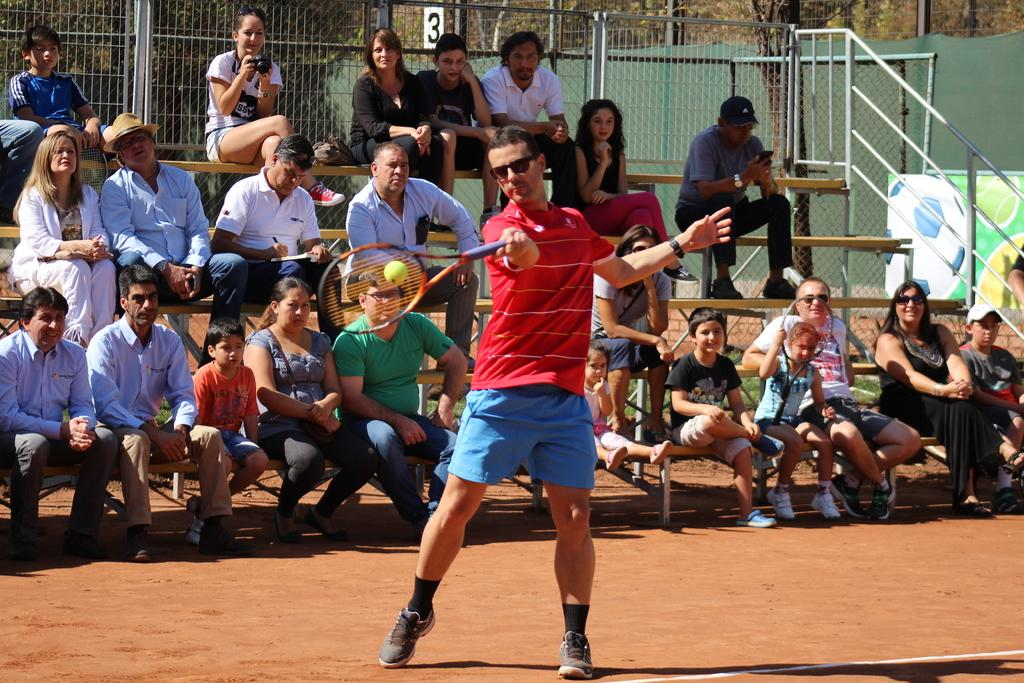<image>
Render a clear and concise summary of the photo. A crowd of people are sitting under the number 3\ 